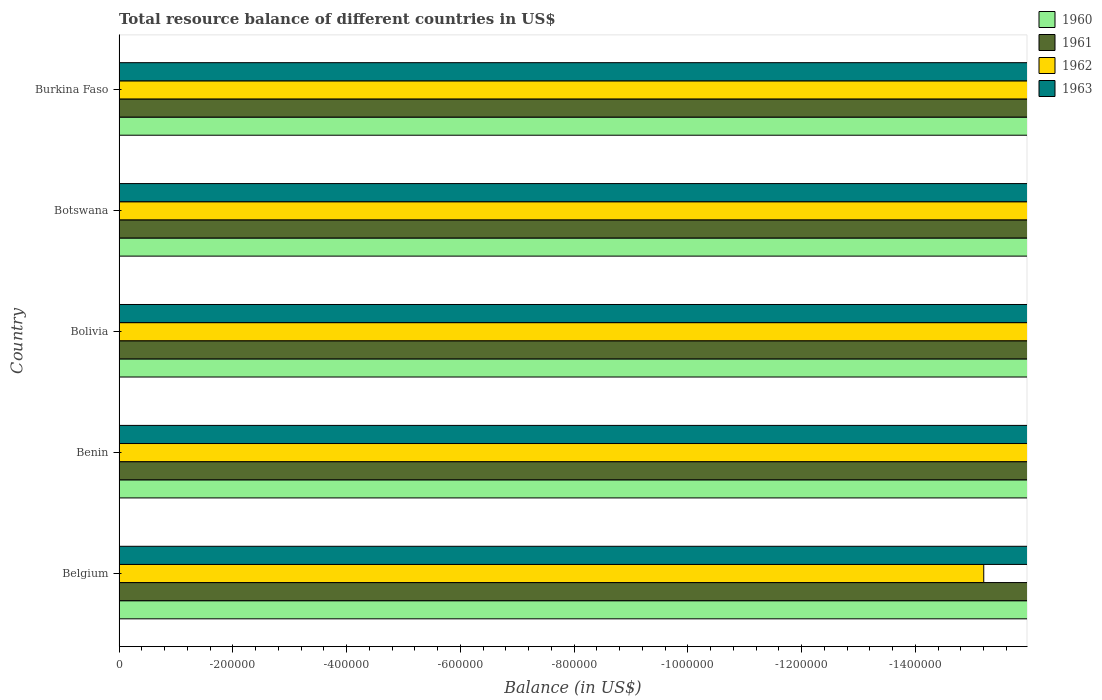How many different coloured bars are there?
Provide a short and direct response. 0. Are the number of bars on each tick of the Y-axis equal?
Give a very brief answer. Yes. How many bars are there on the 5th tick from the bottom?
Ensure brevity in your answer.  0. What is the label of the 1st group of bars from the top?
Ensure brevity in your answer.  Burkina Faso. What is the total total resource balance in 1961 in the graph?
Your answer should be very brief. 0. Is it the case that in every country, the sum of the total resource balance in 1961 and total resource balance in 1962 is greater than the sum of total resource balance in 1960 and total resource balance in 1963?
Provide a short and direct response. No. How many bars are there?
Your answer should be very brief. 0. Are all the bars in the graph horizontal?
Provide a succinct answer. Yes. Does the graph contain grids?
Your response must be concise. No. How many legend labels are there?
Keep it short and to the point. 4. How are the legend labels stacked?
Provide a short and direct response. Vertical. What is the title of the graph?
Offer a very short reply. Total resource balance of different countries in US$. What is the label or title of the X-axis?
Give a very brief answer. Balance (in US$). What is the Balance (in US$) of 1962 in Belgium?
Provide a short and direct response. 0. What is the Balance (in US$) of 1963 in Belgium?
Offer a very short reply. 0. What is the Balance (in US$) of 1960 in Benin?
Give a very brief answer. 0. What is the Balance (in US$) in 1962 in Benin?
Give a very brief answer. 0. What is the Balance (in US$) in 1960 in Bolivia?
Your answer should be very brief. 0. What is the Balance (in US$) in 1961 in Bolivia?
Your answer should be very brief. 0. What is the Balance (in US$) in 1962 in Bolivia?
Provide a succinct answer. 0. What is the Balance (in US$) of 1962 in Botswana?
Make the answer very short. 0. What is the Balance (in US$) of 1960 in Burkina Faso?
Ensure brevity in your answer.  0. What is the Balance (in US$) in 1962 in Burkina Faso?
Your response must be concise. 0. What is the total Balance (in US$) of 1960 in the graph?
Make the answer very short. 0. What is the total Balance (in US$) of 1961 in the graph?
Offer a very short reply. 0. What is the total Balance (in US$) in 1962 in the graph?
Offer a very short reply. 0. What is the average Balance (in US$) in 1960 per country?
Offer a very short reply. 0. 